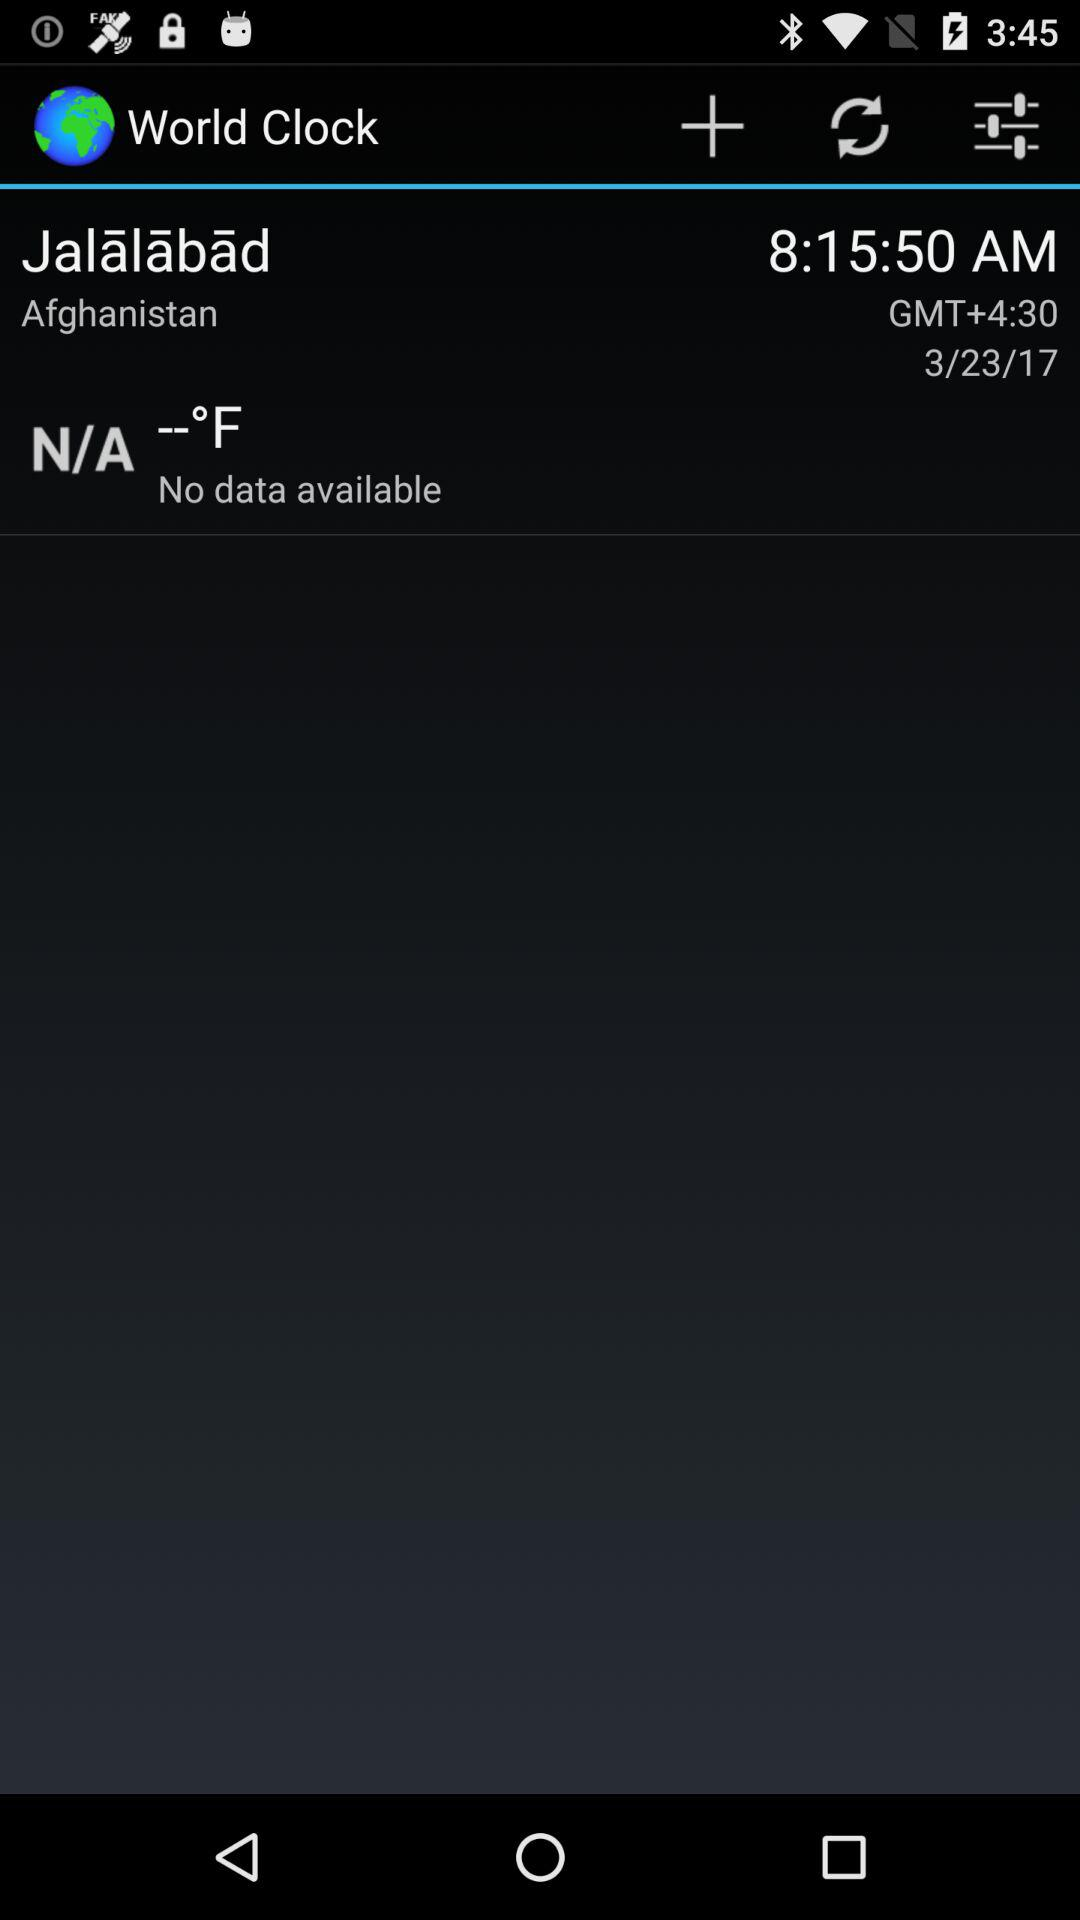What is the date shown? The date shown is March 23, 2017. 